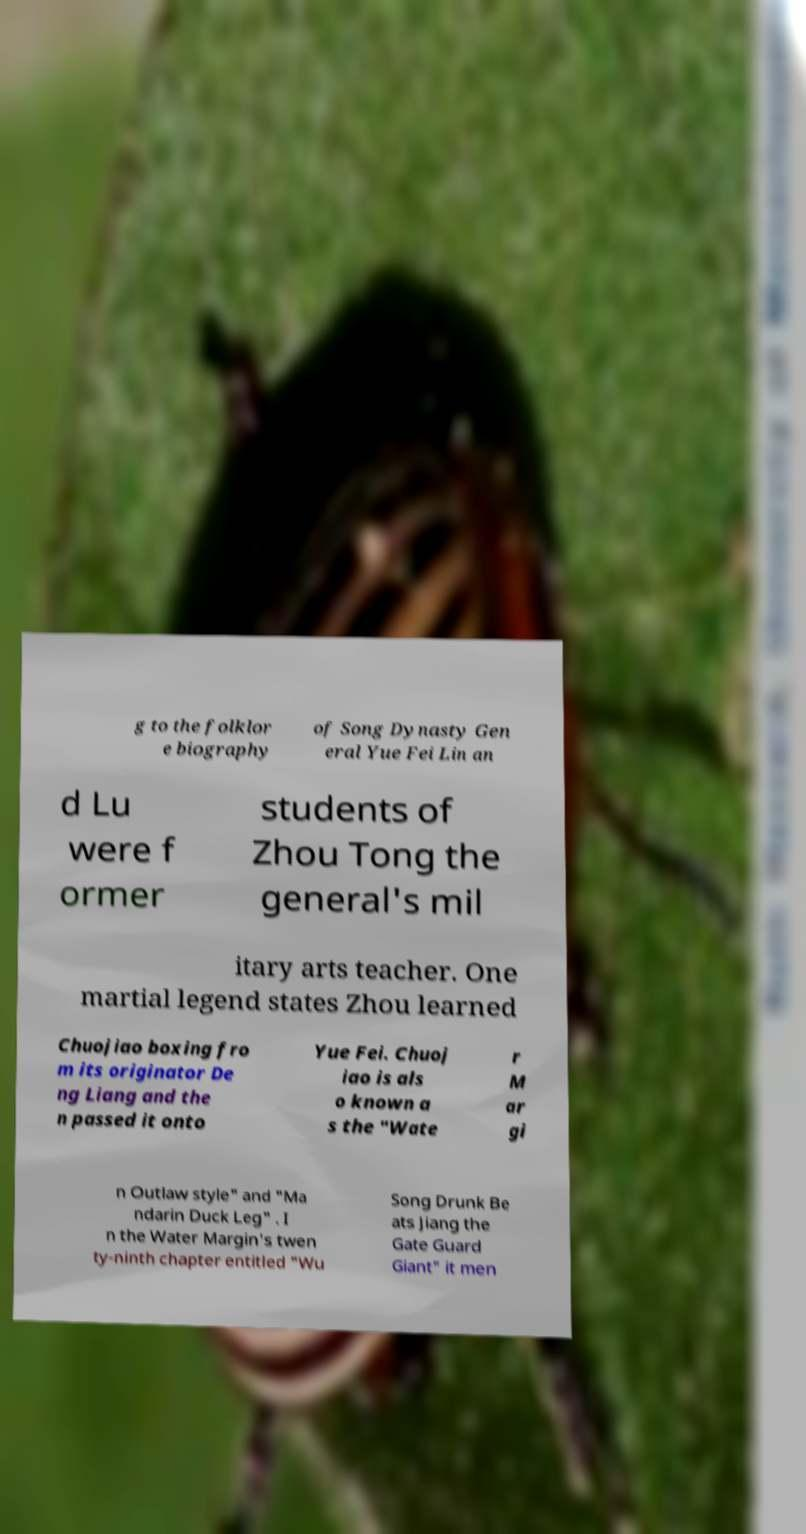For documentation purposes, I need the text within this image transcribed. Could you provide that? g to the folklor e biography of Song Dynasty Gen eral Yue Fei Lin an d Lu were f ormer students of Zhou Tong the general's mil itary arts teacher. One martial legend states Zhou learned Chuojiao boxing fro m its originator De ng Liang and the n passed it onto Yue Fei. Chuoj iao is als o known a s the "Wate r M ar gi n Outlaw style" and "Ma ndarin Duck Leg" . I n the Water Margin's twen ty-ninth chapter entitled "Wu Song Drunk Be ats Jiang the Gate Guard Giant" it men 